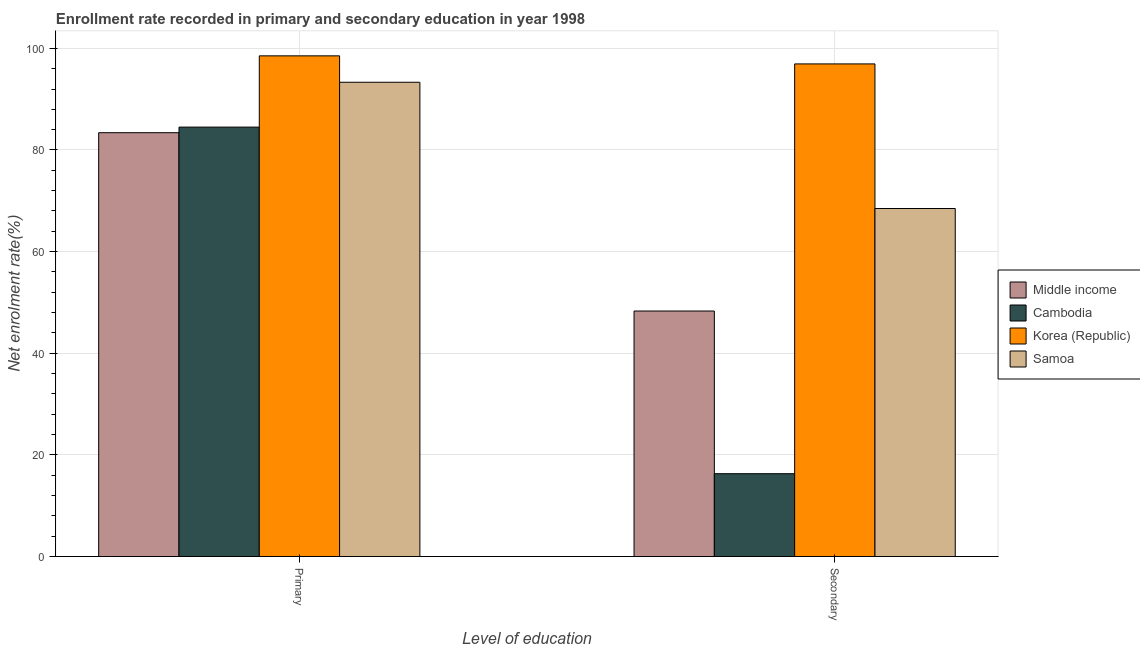How many different coloured bars are there?
Give a very brief answer. 4. What is the label of the 1st group of bars from the left?
Provide a succinct answer. Primary. What is the enrollment rate in secondary education in Samoa?
Your answer should be very brief. 68.49. Across all countries, what is the maximum enrollment rate in secondary education?
Offer a very short reply. 96.94. Across all countries, what is the minimum enrollment rate in secondary education?
Your answer should be very brief. 16.3. In which country was the enrollment rate in primary education minimum?
Keep it short and to the point. Middle income. What is the total enrollment rate in primary education in the graph?
Provide a succinct answer. 359.76. What is the difference between the enrollment rate in primary education in Middle income and that in Cambodia?
Provide a short and direct response. -1.1. What is the difference between the enrollment rate in primary education in Korea (Republic) and the enrollment rate in secondary education in Middle income?
Provide a succinct answer. 50.21. What is the average enrollment rate in secondary education per country?
Provide a short and direct response. 57.51. What is the difference between the enrollment rate in secondary education and enrollment rate in primary education in Cambodia?
Provide a short and direct response. -68.2. What is the ratio of the enrollment rate in primary education in Samoa to that in Cambodia?
Offer a very short reply. 1.1. How many bars are there?
Ensure brevity in your answer.  8. Are all the bars in the graph horizontal?
Provide a short and direct response. No. Are the values on the major ticks of Y-axis written in scientific E-notation?
Offer a very short reply. No. How many legend labels are there?
Offer a terse response. 4. How are the legend labels stacked?
Your answer should be compact. Vertical. What is the title of the graph?
Provide a succinct answer. Enrollment rate recorded in primary and secondary education in year 1998. What is the label or title of the X-axis?
Keep it short and to the point. Level of education. What is the label or title of the Y-axis?
Provide a succinct answer. Net enrolment rate(%). What is the Net enrolment rate(%) in Middle income in Primary?
Keep it short and to the point. 83.4. What is the Net enrolment rate(%) of Cambodia in Primary?
Offer a terse response. 84.5. What is the Net enrolment rate(%) in Korea (Republic) in Primary?
Provide a succinct answer. 98.52. What is the Net enrolment rate(%) in Samoa in Primary?
Your answer should be compact. 93.33. What is the Net enrolment rate(%) in Middle income in Secondary?
Your answer should be very brief. 48.31. What is the Net enrolment rate(%) in Cambodia in Secondary?
Give a very brief answer. 16.3. What is the Net enrolment rate(%) of Korea (Republic) in Secondary?
Provide a short and direct response. 96.94. What is the Net enrolment rate(%) of Samoa in Secondary?
Offer a terse response. 68.49. Across all Level of education, what is the maximum Net enrolment rate(%) in Middle income?
Offer a very short reply. 83.4. Across all Level of education, what is the maximum Net enrolment rate(%) in Cambodia?
Give a very brief answer. 84.5. Across all Level of education, what is the maximum Net enrolment rate(%) in Korea (Republic)?
Your answer should be very brief. 98.52. Across all Level of education, what is the maximum Net enrolment rate(%) of Samoa?
Provide a succinct answer. 93.33. Across all Level of education, what is the minimum Net enrolment rate(%) of Middle income?
Ensure brevity in your answer.  48.31. Across all Level of education, what is the minimum Net enrolment rate(%) of Cambodia?
Keep it short and to the point. 16.3. Across all Level of education, what is the minimum Net enrolment rate(%) of Korea (Republic)?
Give a very brief answer. 96.94. Across all Level of education, what is the minimum Net enrolment rate(%) in Samoa?
Give a very brief answer. 68.49. What is the total Net enrolment rate(%) of Middle income in the graph?
Make the answer very short. 131.71. What is the total Net enrolment rate(%) in Cambodia in the graph?
Provide a short and direct response. 100.8. What is the total Net enrolment rate(%) of Korea (Republic) in the graph?
Offer a terse response. 195.46. What is the total Net enrolment rate(%) in Samoa in the graph?
Keep it short and to the point. 161.82. What is the difference between the Net enrolment rate(%) of Middle income in Primary and that in Secondary?
Provide a short and direct response. 35.09. What is the difference between the Net enrolment rate(%) of Cambodia in Primary and that in Secondary?
Your response must be concise. 68.2. What is the difference between the Net enrolment rate(%) in Korea (Republic) in Primary and that in Secondary?
Give a very brief answer. 1.59. What is the difference between the Net enrolment rate(%) in Samoa in Primary and that in Secondary?
Provide a succinct answer. 24.84. What is the difference between the Net enrolment rate(%) of Middle income in Primary and the Net enrolment rate(%) of Cambodia in Secondary?
Your answer should be compact. 67.1. What is the difference between the Net enrolment rate(%) in Middle income in Primary and the Net enrolment rate(%) in Korea (Republic) in Secondary?
Give a very brief answer. -13.53. What is the difference between the Net enrolment rate(%) in Middle income in Primary and the Net enrolment rate(%) in Samoa in Secondary?
Offer a very short reply. 14.92. What is the difference between the Net enrolment rate(%) of Cambodia in Primary and the Net enrolment rate(%) of Korea (Republic) in Secondary?
Ensure brevity in your answer.  -12.44. What is the difference between the Net enrolment rate(%) of Cambodia in Primary and the Net enrolment rate(%) of Samoa in Secondary?
Make the answer very short. 16.02. What is the difference between the Net enrolment rate(%) of Korea (Republic) in Primary and the Net enrolment rate(%) of Samoa in Secondary?
Offer a terse response. 30.04. What is the average Net enrolment rate(%) of Middle income per Level of education?
Provide a short and direct response. 65.86. What is the average Net enrolment rate(%) of Cambodia per Level of education?
Provide a short and direct response. 50.4. What is the average Net enrolment rate(%) in Korea (Republic) per Level of education?
Provide a succinct answer. 97.73. What is the average Net enrolment rate(%) in Samoa per Level of education?
Offer a very short reply. 80.91. What is the difference between the Net enrolment rate(%) of Middle income and Net enrolment rate(%) of Cambodia in Primary?
Keep it short and to the point. -1.1. What is the difference between the Net enrolment rate(%) of Middle income and Net enrolment rate(%) of Korea (Republic) in Primary?
Your response must be concise. -15.12. What is the difference between the Net enrolment rate(%) of Middle income and Net enrolment rate(%) of Samoa in Primary?
Keep it short and to the point. -9.93. What is the difference between the Net enrolment rate(%) in Cambodia and Net enrolment rate(%) in Korea (Republic) in Primary?
Your response must be concise. -14.02. What is the difference between the Net enrolment rate(%) in Cambodia and Net enrolment rate(%) in Samoa in Primary?
Provide a short and direct response. -8.83. What is the difference between the Net enrolment rate(%) of Korea (Republic) and Net enrolment rate(%) of Samoa in Primary?
Give a very brief answer. 5.19. What is the difference between the Net enrolment rate(%) in Middle income and Net enrolment rate(%) in Cambodia in Secondary?
Keep it short and to the point. 32.01. What is the difference between the Net enrolment rate(%) in Middle income and Net enrolment rate(%) in Korea (Republic) in Secondary?
Your answer should be very brief. -48.63. What is the difference between the Net enrolment rate(%) of Middle income and Net enrolment rate(%) of Samoa in Secondary?
Keep it short and to the point. -20.18. What is the difference between the Net enrolment rate(%) in Cambodia and Net enrolment rate(%) in Korea (Republic) in Secondary?
Ensure brevity in your answer.  -80.64. What is the difference between the Net enrolment rate(%) in Cambodia and Net enrolment rate(%) in Samoa in Secondary?
Provide a succinct answer. -52.19. What is the difference between the Net enrolment rate(%) in Korea (Republic) and Net enrolment rate(%) in Samoa in Secondary?
Your response must be concise. 28.45. What is the ratio of the Net enrolment rate(%) in Middle income in Primary to that in Secondary?
Keep it short and to the point. 1.73. What is the ratio of the Net enrolment rate(%) in Cambodia in Primary to that in Secondary?
Provide a short and direct response. 5.18. What is the ratio of the Net enrolment rate(%) of Korea (Republic) in Primary to that in Secondary?
Provide a succinct answer. 1.02. What is the ratio of the Net enrolment rate(%) of Samoa in Primary to that in Secondary?
Give a very brief answer. 1.36. What is the difference between the highest and the second highest Net enrolment rate(%) of Middle income?
Offer a very short reply. 35.09. What is the difference between the highest and the second highest Net enrolment rate(%) of Cambodia?
Provide a succinct answer. 68.2. What is the difference between the highest and the second highest Net enrolment rate(%) in Korea (Republic)?
Offer a terse response. 1.59. What is the difference between the highest and the second highest Net enrolment rate(%) in Samoa?
Offer a terse response. 24.84. What is the difference between the highest and the lowest Net enrolment rate(%) in Middle income?
Keep it short and to the point. 35.09. What is the difference between the highest and the lowest Net enrolment rate(%) in Cambodia?
Keep it short and to the point. 68.2. What is the difference between the highest and the lowest Net enrolment rate(%) in Korea (Republic)?
Provide a succinct answer. 1.59. What is the difference between the highest and the lowest Net enrolment rate(%) in Samoa?
Provide a succinct answer. 24.84. 